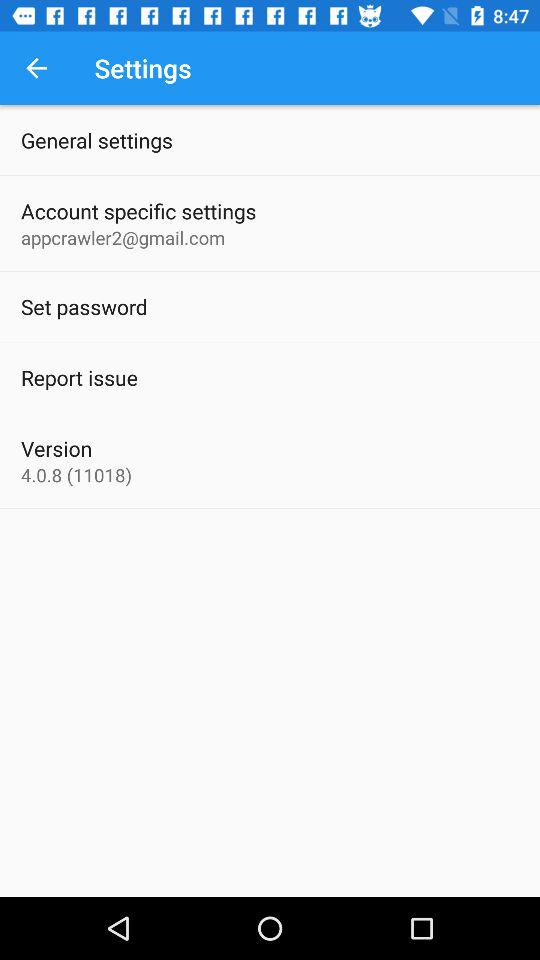What is the email address? The email address is appcrawler2@gmail.com. 